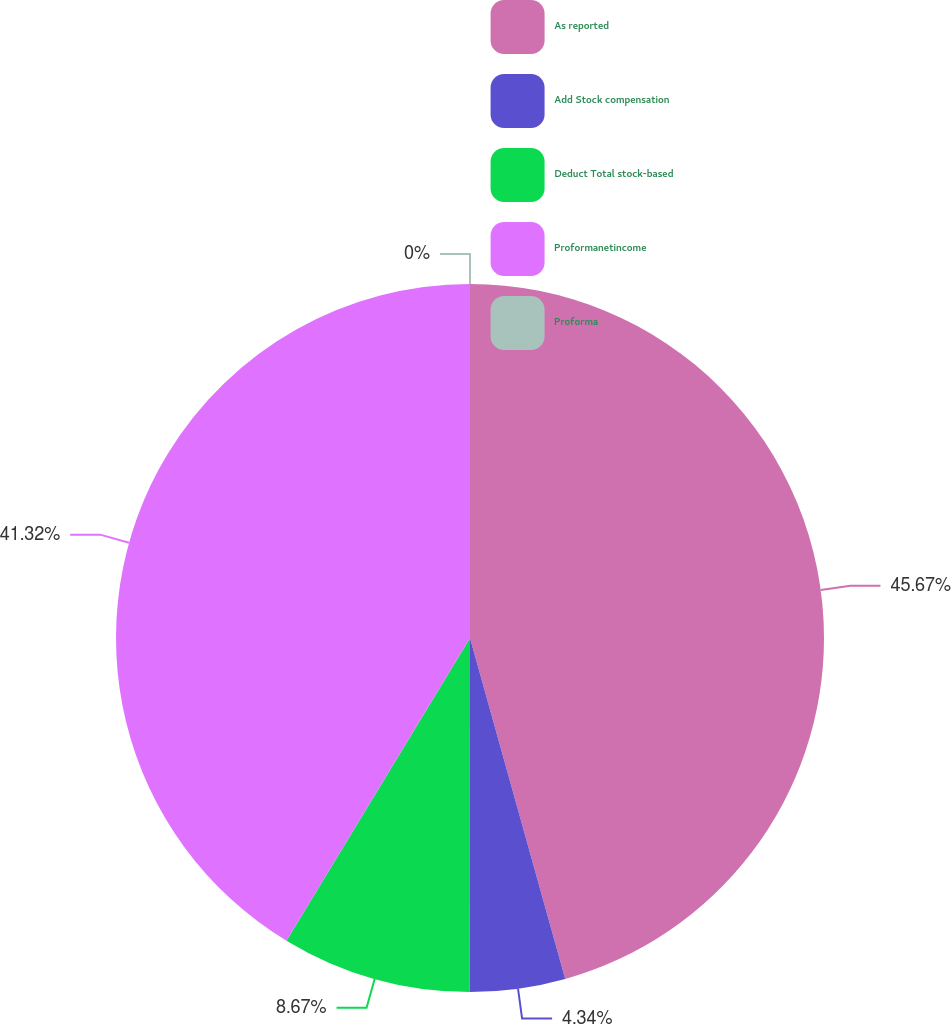Convert chart. <chart><loc_0><loc_0><loc_500><loc_500><pie_chart><fcel>As reported<fcel>Add Stock compensation<fcel>Deduct Total stock-based<fcel>Proformanetincome<fcel>Proforma<nl><fcel>45.66%<fcel>4.34%<fcel>8.67%<fcel>41.32%<fcel>0.0%<nl></chart> 